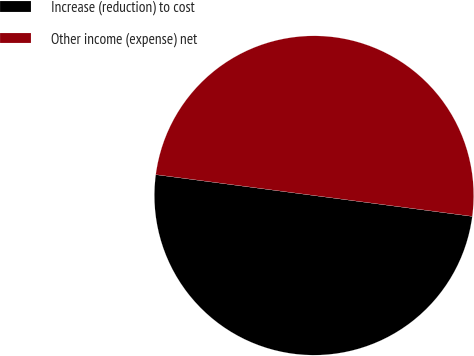Convert chart to OTSL. <chart><loc_0><loc_0><loc_500><loc_500><pie_chart><fcel>Increase (reduction) to cost<fcel>Other income (expense) net<nl><fcel>50.0%<fcel>50.0%<nl></chart> 